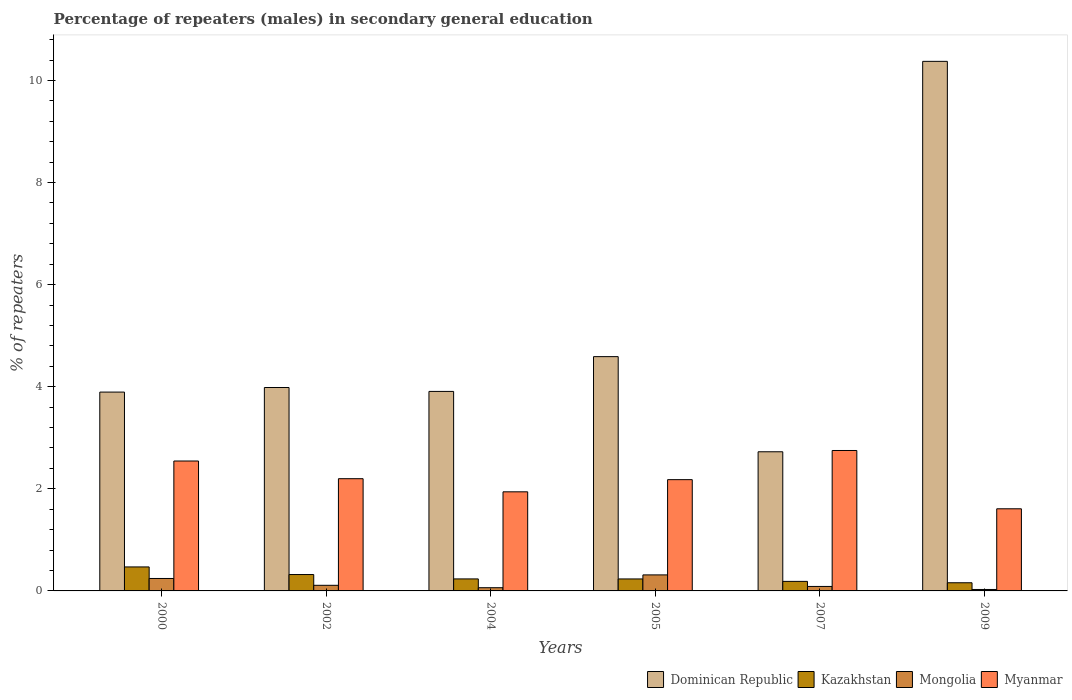How many different coloured bars are there?
Provide a succinct answer. 4. How many groups of bars are there?
Give a very brief answer. 6. Are the number of bars per tick equal to the number of legend labels?
Ensure brevity in your answer.  Yes. Are the number of bars on each tick of the X-axis equal?
Offer a very short reply. Yes. How many bars are there on the 4th tick from the left?
Provide a succinct answer. 4. How many bars are there on the 4th tick from the right?
Your answer should be very brief. 4. In how many cases, is the number of bars for a given year not equal to the number of legend labels?
Your response must be concise. 0. What is the percentage of male repeaters in Dominican Republic in 2009?
Make the answer very short. 10.37. Across all years, what is the maximum percentage of male repeaters in Dominican Republic?
Provide a succinct answer. 10.37. Across all years, what is the minimum percentage of male repeaters in Kazakhstan?
Your response must be concise. 0.16. What is the total percentage of male repeaters in Mongolia in the graph?
Your response must be concise. 0.85. What is the difference between the percentage of male repeaters in Kazakhstan in 2007 and that in 2009?
Ensure brevity in your answer.  0.03. What is the difference between the percentage of male repeaters in Mongolia in 2005 and the percentage of male repeaters in Myanmar in 2002?
Your answer should be very brief. -1.88. What is the average percentage of male repeaters in Dominican Republic per year?
Offer a terse response. 4.91. In the year 2004, what is the difference between the percentage of male repeaters in Kazakhstan and percentage of male repeaters in Myanmar?
Your answer should be compact. -1.71. In how many years, is the percentage of male repeaters in Mongolia greater than 4.8 %?
Offer a terse response. 0. What is the ratio of the percentage of male repeaters in Mongolia in 2002 to that in 2005?
Provide a succinct answer. 0.35. Is the percentage of male repeaters in Myanmar in 2004 less than that in 2005?
Your response must be concise. Yes. What is the difference between the highest and the second highest percentage of male repeaters in Dominican Republic?
Your answer should be very brief. 5.78. What is the difference between the highest and the lowest percentage of male repeaters in Myanmar?
Provide a short and direct response. 1.14. Is the sum of the percentage of male repeaters in Dominican Republic in 2002 and 2004 greater than the maximum percentage of male repeaters in Kazakhstan across all years?
Provide a short and direct response. Yes. Is it the case that in every year, the sum of the percentage of male repeaters in Myanmar and percentage of male repeaters in Dominican Republic is greater than the sum of percentage of male repeaters in Mongolia and percentage of male repeaters in Kazakhstan?
Make the answer very short. Yes. What does the 1st bar from the left in 2004 represents?
Keep it short and to the point. Dominican Republic. What does the 1st bar from the right in 2004 represents?
Make the answer very short. Myanmar. How many bars are there?
Your answer should be compact. 24. Are all the bars in the graph horizontal?
Offer a terse response. No. What is the difference between two consecutive major ticks on the Y-axis?
Your answer should be compact. 2. Does the graph contain grids?
Keep it short and to the point. No. How are the legend labels stacked?
Your answer should be compact. Horizontal. What is the title of the graph?
Provide a succinct answer. Percentage of repeaters (males) in secondary general education. What is the label or title of the Y-axis?
Your answer should be very brief. % of repeaters. What is the % of repeaters of Dominican Republic in 2000?
Provide a short and direct response. 3.9. What is the % of repeaters of Kazakhstan in 2000?
Keep it short and to the point. 0.47. What is the % of repeaters of Mongolia in 2000?
Provide a short and direct response. 0.24. What is the % of repeaters of Myanmar in 2000?
Make the answer very short. 2.55. What is the % of repeaters of Dominican Republic in 2002?
Give a very brief answer. 3.98. What is the % of repeaters of Kazakhstan in 2002?
Make the answer very short. 0.32. What is the % of repeaters of Mongolia in 2002?
Your answer should be very brief. 0.11. What is the % of repeaters in Myanmar in 2002?
Offer a terse response. 2.2. What is the % of repeaters of Dominican Republic in 2004?
Offer a terse response. 3.91. What is the % of repeaters of Kazakhstan in 2004?
Provide a short and direct response. 0.24. What is the % of repeaters of Mongolia in 2004?
Provide a short and direct response. 0.06. What is the % of repeaters of Myanmar in 2004?
Give a very brief answer. 1.94. What is the % of repeaters in Dominican Republic in 2005?
Provide a succinct answer. 4.59. What is the % of repeaters of Kazakhstan in 2005?
Offer a very short reply. 0.23. What is the % of repeaters of Mongolia in 2005?
Keep it short and to the point. 0.31. What is the % of repeaters in Myanmar in 2005?
Offer a terse response. 2.18. What is the % of repeaters in Dominican Republic in 2007?
Give a very brief answer. 2.73. What is the % of repeaters of Kazakhstan in 2007?
Offer a very short reply. 0.19. What is the % of repeaters of Mongolia in 2007?
Your answer should be very brief. 0.09. What is the % of repeaters of Myanmar in 2007?
Ensure brevity in your answer.  2.75. What is the % of repeaters in Dominican Republic in 2009?
Your answer should be compact. 10.37. What is the % of repeaters in Kazakhstan in 2009?
Ensure brevity in your answer.  0.16. What is the % of repeaters of Mongolia in 2009?
Ensure brevity in your answer.  0.03. What is the % of repeaters in Myanmar in 2009?
Keep it short and to the point. 1.61. Across all years, what is the maximum % of repeaters of Dominican Republic?
Keep it short and to the point. 10.37. Across all years, what is the maximum % of repeaters of Kazakhstan?
Offer a very short reply. 0.47. Across all years, what is the maximum % of repeaters of Mongolia?
Offer a very short reply. 0.31. Across all years, what is the maximum % of repeaters in Myanmar?
Make the answer very short. 2.75. Across all years, what is the minimum % of repeaters in Dominican Republic?
Your response must be concise. 2.73. Across all years, what is the minimum % of repeaters in Kazakhstan?
Offer a terse response. 0.16. Across all years, what is the minimum % of repeaters in Mongolia?
Make the answer very short. 0.03. Across all years, what is the minimum % of repeaters of Myanmar?
Make the answer very short. 1.61. What is the total % of repeaters of Dominican Republic in the graph?
Ensure brevity in your answer.  29.48. What is the total % of repeaters of Kazakhstan in the graph?
Offer a very short reply. 1.61. What is the total % of repeaters in Mongolia in the graph?
Ensure brevity in your answer.  0.85. What is the total % of repeaters in Myanmar in the graph?
Your answer should be compact. 13.22. What is the difference between the % of repeaters in Dominican Republic in 2000 and that in 2002?
Give a very brief answer. -0.09. What is the difference between the % of repeaters in Kazakhstan in 2000 and that in 2002?
Ensure brevity in your answer.  0.15. What is the difference between the % of repeaters of Mongolia in 2000 and that in 2002?
Ensure brevity in your answer.  0.13. What is the difference between the % of repeaters in Myanmar in 2000 and that in 2002?
Ensure brevity in your answer.  0.35. What is the difference between the % of repeaters in Dominican Republic in 2000 and that in 2004?
Keep it short and to the point. -0.01. What is the difference between the % of repeaters of Kazakhstan in 2000 and that in 2004?
Offer a very short reply. 0.23. What is the difference between the % of repeaters in Mongolia in 2000 and that in 2004?
Your response must be concise. 0.18. What is the difference between the % of repeaters in Myanmar in 2000 and that in 2004?
Offer a very short reply. 0.6. What is the difference between the % of repeaters of Dominican Republic in 2000 and that in 2005?
Keep it short and to the point. -0.69. What is the difference between the % of repeaters in Kazakhstan in 2000 and that in 2005?
Keep it short and to the point. 0.24. What is the difference between the % of repeaters in Mongolia in 2000 and that in 2005?
Your answer should be compact. -0.07. What is the difference between the % of repeaters of Myanmar in 2000 and that in 2005?
Your response must be concise. 0.37. What is the difference between the % of repeaters of Dominican Republic in 2000 and that in 2007?
Provide a succinct answer. 1.17. What is the difference between the % of repeaters in Kazakhstan in 2000 and that in 2007?
Your answer should be compact. 0.28. What is the difference between the % of repeaters in Mongolia in 2000 and that in 2007?
Provide a short and direct response. 0.16. What is the difference between the % of repeaters in Myanmar in 2000 and that in 2007?
Offer a terse response. -0.21. What is the difference between the % of repeaters of Dominican Republic in 2000 and that in 2009?
Keep it short and to the point. -6.48. What is the difference between the % of repeaters of Kazakhstan in 2000 and that in 2009?
Keep it short and to the point. 0.31. What is the difference between the % of repeaters of Mongolia in 2000 and that in 2009?
Offer a very short reply. 0.22. What is the difference between the % of repeaters of Myanmar in 2000 and that in 2009?
Make the answer very short. 0.94. What is the difference between the % of repeaters of Dominican Republic in 2002 and that in 2004?
Make the answer very short. 0.08. What is the difference between the % of repeaters of Kazakhstan in 2002 and that in 2004?
Provide a succinct answer. 0.09. What is the difference between the % of repeaters of Mongolia in 2002 and that in 2004?
Make the answer very short. 0.05. What is the difference between the % of repeaters of Myanmar in 2002 and that in 2004?
Make the answer very short. 0.26. What is the difference between the % of repeaters of Dominican Republic in 2002 and that in 2005?
Ensure brevity in your answer.  -0.6. What is the difference between the % of repeaters of Kazakhstan in 2002 and that in 2005?
Give a very brief answer. 0.09. What is the difference between the % of repeaters of Mongolia in 2002 and that in 2005?
Provide a short and direct response. -0.2. What is the difference between the % of repeaters of Myanmar in 2002 and that in 2005?
Your answer should be very brief. 0.02. What is the difference between the % of repeaters of Dominican Republic in 2002 and that in 2007?
Your response must be concise. 1.26. What is the difference between the % of repeaters in Kazakhstan in 2002 and that in 2007?
Keep it short and to the point. 0.13. What is the difference between the % of repeaters of Mongolia in 2002 and that in 2007?
Provide a succinct answer. 0.02. What is the difference between the % of repeaters in Myanmar in 2002 and that in 2007?
Offer a terse response. -0.55. What is the difference between the % of repeaters of Dominican Republic in 2002 and that in 2009?
Keep it short and to the point. -6.39. What is the difference between the % of repeaters of Kazakhstan in 2002 and that in 2009?
Your answer should be compact. 0.16. What is the difference between the % of repeaters of Mongolia in 2002 and that in 2009?
Give a very brief answer. 0.08. What is the difference between the % of repeaters of Myanmar in 2002 and that in 2009?
Ensure brevity in your answer.  0.59. What is the difference between the % of repeaters in Dominican Republic in 2004 and that in 2005?
Give a very brief answer. -0.68. What is the difference between the % of repeaters of Kazakhstan in 2004 and that in 2005?
Keep it short and to the point. 0. What is the difference between the % of repeaters of Mongolia in 2004 and that in 2005?
Your answer should be very brief. -0.25. What is the difference between the % of repeaters of Myanmar in 2004 and that in 2005?
Provide a succinct answer. -0.24. What is the difference between the % of repeaters in Dominican Republic in 2004 and that in 2007?
Provide a short and direct response. 1.18. What is the difference between the % of repeaters in Kazakhstan in 2004 and that in 2007?
Provide a succinct answer. 0.05. What is the difference between the % of repeaters of Mongolia in 2004 and that in 2007?
Make the answer very short. -0.02. What is the difference between the % of repeaters in Myanmar in 2004 and that in 2007?
Offer a very short reply. -0.81. What is the difference between the % of repeaters in Dominican Republic in 2004 and that in 2009?
Make the answer very short. -6.47. What is the difference between the % of repeaters of Kazakhstan in 2004 and that in 2009?
Your response must be concise. 0.08. What is the difference between the % of repeaters in Mongolia in 2004 and that in 2009?
Keep it short and to the point. 0.03. What is the difference between the % of repeaters of Myanmar in 2004 and that in 2009?
Your answer should be very brief. 0.33. What is the difference between the % of repeaters of Dominican Republic in 2005 and that in 2007?
Offer a terse response. 1.86. What is the difference between the % of repeaters of Kazakhstan in 2005 and that in 2007?
Keep it short and to the point. 0.05. What is the difference between the % of repeaters in Mongolia in 2005 and that in 2007?
Your answer should be very brief. 0.23. What is the difference between the % of repeaters of Myanmar in 2005 and that in 2007?
Offer a terse response. -0.57. What is the difference between the % of repeaters of Dominican Republic in 2005 and that in 2009?
Make the answer very short. -5.78. What is the difference between the % of repeaters in Kazakhstan in 2005 and that in 2009?
Your answer should be compact. 0.07. What is the difference between the % of repeaters in Mongolia in 2005 and that in 2009?
Your answer should be compact. 0.29. What is the difference between the % of repeaters in Myanmar in 2005 and that in 2009?
Keep it short and to the point. 0.57. What is the difference between the % of repeaters in Dominican Republic in 2007 and that in 2009?
Offer a terse response. -7.65. What is the difference between the % of repeaters in Kazakhstan in 2007 and that in 2009?
Keep it short and to the point. 0.03. What is the difference between the % of repeaters in Mongolia in 2007 and that in 2009?
Offer a terse response. 0.06. What is the difference between the % of repeaters of Myanmar in 2007 and that in 2009?
Provide a short and direct response. 1.14. What is the difference between the % of repeaters of Dominican Republic in 2000 and the % of repeaters of Kazakhstan in 2002?
Ensure brevity in your answer.  3.57. What is the difference between the % of repeaters of Dominican Republic in 2000 and the % of repeaters of Mongolia in 2002?
Provide a short and direct response. 3.79. What is the difference between the % of repeaters in Dominican Republic in 2000 and the % of repeaters in Myanmar in 2002?
Offer a terse response. 1.7. What is the difference between the % of repeaters in Kazakhstan in 2000 and the % of repeaters in Mongolia in 2002?
Offer a very short reply. 0.36. What is the difference between the % of repeaters of Kazakhstan in 2000 and the % of repeaters of Myanmar in 2002?
Provide a succinct answer. -1.73. What is the difference between the % of repeaters in Mongolia in 2000 and the % of repeaters in Myanmar in 2002?
Offer a terse response. -1.95. What is the difference between the % of repeaters of Dominican Republic in 2000 and the % of repeaters of Kazakhstan in 2004?
Provide a short and direct response. 3.66. What is the difference between the % of repeaters in Dominican Republic in 2000 and the % of repeaters in Mongolia in 2004?
Your response must be concise. 3.83. What is the difference between the % of repeaters in Dominican Republic in 2000 and the % of repeaters in Myanmar in 2004?
Give a very brief answer. 1.95. What is the difference between the % of repeaters of Kazakhstan in 2000 and the % of repeaters of Mongolia in 2004?
Give a very brief answer. 0.41. What is the difference between the % of repeaters of Kazakhstan in 2000 and the % of repeaters of Myanmar in 2004?
Ensure brevity in your answer.  -1.47. What is the difference between the % of repeaters of Mongolia in 2000 and the % of repeaters of Myanmar in 2004?
Ensure brevity in your answer.  -1.7. What is the difference between the % of repeaters of Dominican Republic in 2000 and the % of repeaters of Kazakhstan in 2005?
Your response must be concise. 3.66. What is the difference between the % of repeaters of Dominican Republic in 2000 and the % of repeaters of Mongolia in 2005?
Provide a succinct answer. 3.58. What is the difference between the % of repeaters in Dominican Republic in 2000 and the % of repeaters in Myanmar in 2005?
Your answer should be very brief. 1.72. What is the difference between the % of repeaters in Kazakhstan in 2000 and the % of repeaters in Mongolia in 2005?
Give a very brief answer. 0.16. What is the difference between the % of repeaters in Kazakhstan in 2000 and the % of repeaters in Myanmar in 2005?
Your response must be concise. -1.71. What is the difference between the % of repeaters in Mongolia in 2000 and the % of repeaters in Myanmar in 2005?
Ensure brevity in your answer.  -1.94. What is the difference between the % of repeaters in Dominican Republic in 2000 and the % of repeaters in Kazakhstan in 2007?
Keep it short and to the point. 3.71. What is the difference between the % of repeaters in Dominican Republic in 2000 and the % of repeaters in Mongolia in 2007?
Offer a very short reply. 3.81. What is the difference between the % of repeaters in Dominican Republic in 2000 and the % of repeaters in Myanmar in 2007?
Make the answer very short. 1.14. What is the difference between the % of repeaters of Kazakhstan in 2000 and the % of repeaters of Mongolia in 2007?
Make the answer very short. 0.38. What is the difference between the % of repeaters in Kazakhstan in 2000 and the % of repeaters in Myanmar in 2007?
Keep it short and to the point. -2.28. What is the difference between the % of repeaters of Mongolia in 2000 and the % of repeaters of Myanmar in 2007?
Provide a short and direct response. -2.51. What is the difference between the % of repeaters in Dominican Republic in 2000 and the % of repeaters in Kazakhstan in 2009?
Ensure brevity in your answer.  3.74. What is the difference between the % of repeaters in Dominican Republic in 2000 and the % of repeaters in Mongolia in 2009?
Offer a terse response. 3.87. What is the difference between the % of repeaters of Dominican Republic in 2000 and the % of repeaters of Myanmar in 2009?
Offer a terse response. 2.29. What is the difference between the % of repeaters of Kazakhstan in 2000 and the % of repeaters of Mongolia in 2009?
Offer a terse response. 0.44. What is the difference between the % of repeaters of Kazakhstan in 2000 and the % of repeaters of Myanmar in 2009?
Your answer should be very brief. -1.14. What is the difference between the % of repeaters of Mongolia in 2000 and the % of repeaters of Myanmar in 2009?
Offer a terse response. -1.37. What is the difference between the % of repeaters of Dominican Republic in 2002 and the % of repeaters of Kazakhstan in 2004?
Keep it short and to the point. 3.75. What is the difference between the % of repeaters of Dominican Republic in 2002 and the % of repeaters of Mongolia in 2004?
Your response must be concise. 3.92. What is the difference between the % of repeaters of Dominican Republic in 2002 and the % of repeaters of Myanmar in 2004?
Offer a very short reply. 2.04. What is the difference between the % of repeaters of Kazakhstan in 2002 and the % of repeaters of Mongolia in 2004?
Ensure brevity in your answer.  0.26. What is the difference between the % of repeaters in Kazakhstan in 2002 and the % of repeaters in Myanmar in 2004?
Offer a terse response. -1.62. What is the difference between the % of repeaters of Mongolia in 2002 and the % of repeaters of Myanmar in 2004?
Offer a terse response. -1.83. What is the difference between the % of repeaters in Dominican Republic in 2002 and the % of repeaters in Kazakhstan in 2005?
Keep it short and to the point. 3.75. What is the difference between the % of repeaters in Dominican Republic in 2002 and the % of repeaters in Mongolia in 2005?
Provide a succinct answer. 3.67. What is the difference between the % of repeaters in Dominican Republic in 2002 and the % of repeaters in Myanmar in 2005?
Provide a succinct answer. 1.8. What is the difference between the % of repeaters in Kazakhstan in 2002 and the % of repeaters in Mongolia in 2005?
Offer a terse response. 0.01. What is the difference between the % of repeaters in Kazakhstan in 2002 and the % of repeaters in Myanmar in 2005?
Provide a short and direct response. -1.86. What is the difference between the % of repeaters of Mongolia in 2002 and the % of repeaters of Myanmar in 2005?
Provide a succinct answer. -2.07. What is the difference between the % of repeaters of Dominican Republic in 2002 and the % of repeaters of Kazakhstan in 2007?
Ensure brevity in your answer.  3.8. What is the difference between the % of repeaters of Dominican Republic in 2002 and the % of repeaters of Mongolia in 2007?
Give a very brief answer. 3.9. What is the difference between the % of repeaters in Dominican Republic in 2002 and the % of repeaters in Myanmar in 2007?
Give a very brief answer. 1.23. What is the difference between the % of repeaters in Kazakhstan in 2002 and the % of repeaters in Mongolia in 2007?
Give a very brief answer. 0.23. What is the difference between the % of repeaters in Kazakhstan in 2002 and the % of repeaters in Myanmar in 2007?
Ensure brevity in your answer.  -2.43. What is the difference between the % of repeaters of Mongolia in 2002 and the % of repeaters of Myanmar in 2007?
Offer a very short reply. -2.64. What is the difference between the % of repeaters of Dominican Republic in 2002 and the % of repeaters of Kazakhstan in 2009?
Offer a very short reply. 3.82. What is the difference between the % of repeaters in Dominican Republic in 2002 and the % of repeaters in Mongolia in 2009?
Provide a succinct answer. 3.96. What is the difference between the % of repeaters of Dominican Republic in 2002 and the % of repeaters of Myanmar in 2009?
Give a very brief answer. 2.38. What is the difference between the % of repeaters of Kazakhstan in 2002 and the % of repeaters of Mongolia in 2009?
Provide a succinct answer. 0.29. What is the difference between the % of repeaters in Kazakhstan in 2002 and the % of repeaters in Myanmar in 2009?
Your answer should be very brief. -1.29. What is the difference between the % of repeaters in Mongolia in 2002 and the % of repeaters in Myanmar in 2009?
Your answer should be compact. -1.5. What is the difference between the % of repeaters of Dominican Republic in 2004 and the % of repeaters of Kazakhstan in 2005?
Offer a very short reply. 3.67. What is the difference between the % of repeaters of Dominican Republic in 2004 and the % of repeaters of Mongolia in 2005?
Offer a very short reply. 3.59. What is the difference between the % of repeaters of Dominican Republic in 2004 and the % of repeaters of Myanmar in 2005?
Make the answer very short. 1.73. What is the difference between the % of repeaters in Kazakhstan in 2004 and the % of repeaters in Mongolia in 2005?
Give a very brief answer. -0.08. What is the difference between the % of repeaters of Kazakhstan in 2004 and the % of repeaters of Myanmar in 2005?
Provide a short and direct response. -1.94. What is the difference between the % of repeaters of Mongolia in 2004 and the % of repeaters of Myanmar in 2005?
Ensure brevity in your answer.  -2.12. What is the difference between the % of repeaters in Dominican Republic in 2004 and the % of repeaters in Kazakhstan in 2007?
Offer a very short reply. 3.72. What is the difference between the % of repeaters of Dominican Republic in 2004 and the % of repeaters of Mongolia in 2007?
Ensure brevity in your answer.  3.82. What is the difference between the % of repeaters of Dominican Republic in 2004 and the % of repeaters of Myanmar in 2007?
Give a very brief answer. 1.16. What is the difference between the % of repeaters in Kazakhstan in 2004 and the % of repeaters in Mongolia in 2007?
Ensure brevity in your answer.  0.15. What is the difference between the % of repeaters in Kazakhstan in 2004 and the % of repeaters in Myanmar in 2007?
Provide a short and direct response. -2.52. What is the difference between the % of repeaters in Mongolia in 2004 and the % of repeaters in Myanmar in 2007?
Offer a terse response. -2.69. What is the difference between the % of repeaters in Dominican Republic in 2004 and the % of repeaters in Kazakhstan in 2009?
Offer a terse response. 3.75. What is the difference between the % of repeaters in Dominican Republic in 2004 and the % of repeaters in Mongolia in 2009?
Your answer should be compact. 3.88. What is the difference between the % of repeaters in Dominican Republic in 2004 and the % of repeaters in Myanmar in 2009?
Ensure brevity in your answer.  2.3. What is the difference between the % of repeaters of Kazakhstan in 2004 and the % of repeaters of Mongolia in 2009?
Give a very brief answer. 0.21. What is the difference between the % of repeaters in Kazakhstan in 2004 and the % of repeaters in Myanmar in 2009?
Ensure brevity in your answer.  -1.37. What is the difference between the % of repeaters in Mongolia in 2004 and the % of repeaters in Myanmar in 2009?
Offer a very short reply. -1.55. What is the difference between the % of repeaters of Dominican Republic in 2005 and the % of repeaters of Kazakhstan in 2007?
Provide a short and direct response. 4.4. What is the difference between the % of repeaters of Dominican Republic in 2005 and the % of repeaters of Mongolia in 2007?
Ensure brevity in your answer.  4.5. What is the difference between the % of repeaters in Dominican Republic in 2005 and the % of repeaters in Myanmar in 2007?
Offer a terse response. 1.84. What is the difference between the % of repeaters of Kazakhstan in 2005 and the % of repeaters of Mongolia in 2007?
Give a very brief answer. 0.15. What is the difference between the % of repeaters in Kazakhstan in 2005 and the % of repeaters in Myanmar in 2007?
Offer a very short reply. -2.52. What is the difference between the % of repeaters in Mongolia in 2005 and the % of repeaters in Myanmar in 2007?
Your answer should be compact. -2.44. What is the difference between the % of repeaters in Dominican Republic in 2005 and the % of repeaters in Kazakhstan in 2009?
Ensure brevity in your answer.  4.43. What is the difference between the % of repeaters of Dominican Republic in 2005 and the % of repeaters of Mongolia in 2009?
Provide a short and direct response. 4.56. What is the difference between the % of repeaters of Dominican Republic in 2005 and the % of repeaters of Myanmar in 2009?
Keep it short and to the point. 2.98. What is the difference between the % of repeaters in Kazakhstan in 2005 and the % of repeaters in Mongolia in 2009?
Your answer should be compact. 0.21. What is the difference between the % of repeaters of Kazakhstan in 2005 and the % of repeaters of Myanmar in 2009?
Offer a very short reply. -1.37. What is the difference between the % of repeaters in Mongolia in 2005 and the % of repeaters in Myanmar in 2009?
Provide a succinct answer. -1.3. What is the difference between the % of repeaters in Dominican Republic in 2007 and the % of repeaters in Kazakhstan in 2009?
Your response must be concise. 2.57. What is the difference between the % of repeaters of Dominican Republic in 2007 and the % of repeaters of Mongolia in 2009?
Offer a very short reply. 2.7. What is the difference between the % of repeaters of Dominican Republic in 2007 and the % of repeaters of Myanmar in 2009?
Provide a succinct answer. 1.12. What is the difference between the % of repeaters of Kazakhstan in 2007 and the % of repeaters of Mongolia in 2009?
Offer a terse response. 0.16. What is the difference between the % of repeaters of Kazakhstan in 2007 and the % of repeaters of Myanmar in 2009?
Make the answer very short. -1.42. What is the difference between the % of repeaters in Mongolia in 2007 and the % of repeaters in Myanmar in 2009?
Provide a short and direct response. -1.52. What is the average % of repeaters in Dominican Republic per year?
Your answer should be compact. 4.91. What is the average % of repeaters in Kazakhstan per year?
Offer a terse response. 0.27. What is the average % of repeaters of Mongolia per year?
Keep it short and to the point. 0.14. What is the average % of repeaters of Myanmar per year?
Keep it short and to the point. 2.2. In the year 2000, what is the difference between the % of repeaters of Dominican Republic and % of repeaters of Kazakhstan?
Your answer should be compact. 3.43. In the year 2000, what is the difference between the % of repeaters in Dominican Republic and % of repeaters in Mongolia?
Keep it short and to the point. 3.65. In the year 2000, what is the difference between the % of repeaters of Dominican Republic and % of repeaters of Myanmar?
Give a very brief answer. 1.35. In the year 2000, what is the difference between the % of repeaters in Kazakhstan and % of repeaters in Mongolia?
Give a very brief answer. 0.23. In the year 2000, what is the difference between the % of repeaters in Kazakhstan and % of repeaters in Myanmar?
Ensure brevity in your answer.  -2.08. In the year 2000, what is the difference between the % of repeaters in Mongolia and % of repeaters in Myanmar?
Keep it short and to the point. -2.3. In the year 2002, what is the difference between the % of repeaters of Dominican Republic and % of repeaters of Kazakhstan?
Offer a very short reply. 3.66. In the year 2002, what is the difference between the % of repeaters in Dominican Republic and % of repeaters in Mongolia?
Your answer should be very brief. 3.87. In the year 2002, what is the difference between the % of repeaters in Dominican Republic and % of repeaters in Myanmar?
Offer a very short reply. 1.79. In the year 2002, what is the difference between the % of repeaters in Kazakhstan and % of repeaters in Mongolia?
Offer a terse response. 0.21. In the year 2002, what is the difference between the % of repeaters in Kazakhstan and % of repeaters in Myanmar?
Provide a succinct answer. -1.88. In the year 2002, what is the difference between the % of repeaters in Mongolia and % of repeaters in Myanmar?
Provide a succinct answer. -2.09. In the year 2004, what is the difference between the % of repeaters in Dominican Republic and % of repeaters in Kazakhstan?
Provide a succinct answer. 3.67. In the year 2004, what is the difference between the % of repeaters in Dominican Republic and % of repeaters in Mongolia?
Keep it short and to the point. 3.85. In the year 2004, what is the difference between the % of repeaters in Dominican Republic and % of repeaters in Myanmar?
Ensure brevity in your answer.  1.97. In the year 2004, what is the difference between the % of repeaters in Kazakhstan and % of repeaters in Mongolia?
Provide a short and direct response. 0.17. In the year 2004, what is the difference between the % of repeaters of Kazakhstan and % of repeaters of Myanmar?
Make the answer very short. -1.71. In the year 2004, what is the difference between the % of repeaters in Mongolia and % of repeaters in Myanmar?
Your answer should be very brief. -1.88. In the year 2005, what is the difference between the % of repeaters of Dominican Republic and % of repeaters of Kazakhstan?
Offer a terse response. 4.36. In the year 2005, what is the difference between the % of repeaters in Dominican Republic and % of repeaters in Mongolia?
Keep it short and to the point. 4.28. In the year 2005, what is the difference between the % of repeaters in Dominican Republic and % of repeaters in Myanmar?
Keep it short and to the point. 2.41. In the year 2005, what is the difference between the % of repeaters of Kazakhstan and % of repeaters of Mongolia?
Your response must be concise. -0.08. In the year 2005, what is the difference between the % of repeaters of Kazakhstan and % of repeaters of Myanmar?
Provide a succinct answer. -1.95. In the year 2005, what is the difference between the % of repeaters in Mongolia and % of repeaters in Myanmar?
Make the answer very short. -1.87. In the year 2007, what is the difference between the % of repeaters of Dominican Republic and % of repeaters of Kazakhstan?
Your answer should be very brief. 2.54. In the year 2007, what is the difference between the % of repeaters in Dominican Republic and % of repeaters in Mongolia?
Your answer should be very brief. 2.64. In the year 2007, what is the difference between the % of repeaters in Dominican Republic and % of repeaters in Myanmar?
Provide a short and direct response. -0.03. In the year 2007, what is the difference between the % of repeaters in Kazakhstan and % of repeaters in Mongolia?
Ensure brevity in your answer.  0.1. In the year 2007, what is the difference between the % of repeaters of Kazakhstan and % of repeaters of Myanmar?
Keep it short and to the point. -2.56. In the year 2007, what is the difference between the % of repeaters of Mongolia and % of repeaters of Myanmar?
Keep it short and to the point. -2.66. In the year 2009, what is the difference between the % of repeaters in Dominican Republic and % of repeaters in Kazakhstan?
Ensure brevity in your answer.  10.21. In the year 2009, what is the difference between the % of repeaters in Dominican Republic and % of repeaters in Mongolia?
Your answer should be very brief. 10.35. In the year 2009, what is the difference between the % of repeaters in Dominican Republic and % of repeaters in Myanmar?
Your answer should be very brief. 8.77. In the year 2009, what is the difference between the % of repeaters in Kazakhstan and % of repeaters in Mongolia?
Give a very brief answer. 0.13. In the year 2009, what is the difference between the % of repeaters in Kazakhstan and % of repeaters in Myanmar?
Offer a terse response. -1.45. In the year 2009, what is the difference between the % of repeaters of Mongolia and % of repeaters of Myanmar?
Offer a terse response. -1.58. What is the ratio of the % of repeaters in Dominican Republic in 2000 to that in 2002?
Make the answer very short. 0.98. What is the ratio of the % of repeaters in Kazakhstan in 2000 to that in 2002?
Offer a very short reply. 1.46. What is the ratio of the % of repeaters in Mongolia in 2000 to that in 2002?
Offer a very short reply. 2.21. What is the ratio of the % of repeaters of Myanmar in 2000 to that in 2002?
Provide a short and direct response. 1.16. What is the ratio of the % of repeaters of Kazakhstan in 2000 to that in 2004?
Make the answer very short. 2. What is the ratio of the % of repeaters in Mongolia in 2000 to that in 2004?
Offer a terse response. 3.87. What is the ratio of the % of repeaters of Myanmar in 2000 to that in 2004?
Offer a terse response. 1.31. What is the ratio of the % of repeaters in Dominican Republic in 2000 to that in 2005?
Offer a very short reply. 0.85. What is the ratio of the % of repeaters in Kazakhstan in 2000 to that in 2005?
Give a very brief answer. 2. What is the ratio of the % of repeaters of Mongolia in 2000 to that in 2005?
Ensure brevity in your answer.  0.78. What is the ratio of the % of repeaters in Myanmar in 2000 to that in 2005?
Make the answer very short. 1.17. What is the ratio of the % of repeaters in Dominican Republic in 2000 to that in 2007?
Your answer should be compact. 1.43. What is the ratio of the % of repeaters of Kazakhstan in 2000 to that in 2007?
Provide a short and direct response. 2.51. What is the ratio of the % of repeaters of Mongolia in 2000 to that in 2007?
Provide a succinct answer. 2.78. What is the ratio of the % of repeaters of Myanmar in 2000 to that in 2007?
Offer a terse response. 0.93. What is the ratio of the % of repeaters of Dominican Republic in 2000 to that in 2009?
Your answer should be compact. 0.38. What is the ratio of the % of repeaters of Kazakhstan in 2000 to that in 2009?
Provide a succinct answer. 2.94. What is the ratio of the % of repeaters in Mongolia in 2000 to that in 2009?
Your response must be concise. 8.62. What is the ratio of the % of repeaters of Myanmar in 2000 to that in 2009?
Keep it short and to the point. 1.58. What is the ratio of the % of repeaters in Dominican Republic in 2002 to that in 2004?
Make the answer very short. 1.02. What is the ratio of the % of repeaters of Kazakhstan in 2002 to that in 2004?
Offer a terse response. 1.36. What is the ratio of the % of repeaters in Mongolia in 2002 to that in 2004?
Keep it short and to the point. 1.75. What is the ratio of the % of repeaters in Myanmar in 2002 to that in 2004?
Make the answer very short. 1.13. What is the ratio of the % of repeaters in Dominican Republic in 2002 to that in 2005?
Provide a succinct answer. 0.87. What is the ratio of the % of repeaters in Kazakhstan in 2002 to that in 2005?
Give a very brief answer. 1.37. What is the ratio of the % of repeaters of Mongolia in 2002 to that in 2005?
Your answer should be compact. 0.35. What is the ratio of the % of repeaters of Myanmar in 2002 to that in 2005?
Provide a short and direct response. 1.01. What is the ratio of the % of repeaters in Dominican Republic in 2002 to that in 2007?
Offer a very short reply. 1.46. What is the ratio of the % of repeaters in Kazakhstan in 2002 to that in 2007?
Offer a terse response. 1.72. What is the ratio of the % of repeaters in Mongolia in 2002 to that in 2007?
Provide a succinct answer. 1.25. What is the ratio of the % of repeaters of Myanmar in 2002 to that in 2007?
Keep it short and to the point. 0.8. What is the ratio of the % of repeaters in Dominican Republic in 2002 to that in 2009?
Offer a terse response. 0.38. What is the ratio of the % of repeaters in Kazakhstan in 2002 to that in 2009?
Give a very brief answer. 2.01. What is the ratio of the % of repeaters in Mongolia in 2002 to that in 2009?
Provide a succinct answer. 3.89. What is the ratio of the % of repeaters in Myanmar in 2002 to that in 2009?
Offer a terse response. 1.37. What is the ratio of the % of repeaters in Dominican Republic in 2004 to that in 2005?
Your answer should be compact. 0.85. What is the ratio of the % of repeaters in Kazakhstan in 2004 to that in 2005?
Offer a very short reply. 1. What is the ratio of the % of repeaters in Mongolia in 2004 to that in 2005?
Give a very brief answer. 0.2. What is the ratio of the % of repeaters in Myanmar in 2004 to that in 2005?
Offer a terse response. 0.89. What is the ratio of the % of repeaters of Dominican Republic in 2004 to that in 2007?
Offer a terse response. 1.43. What is the ratio of the % of repeaters in Kazakhstan in 2004 to that in 2007?
Give a very brief answer. 1.26. What is the ratio of the % of repeaters of Mongolia in 2004 to that in 2007?
Ensure brevity in your answer.  0.72. What is the ratio of the % of repeaters of Myanmar in 2004 to that in 2007?
Offer a terse response. 0.71. What is the ratio of the % of repeaters of Dominican Republic in 2004 to that in 2009?
Your answer should be compact. 0.38. What is the ratio of the % of repeaters in Kazakhstan in 2004 to that in 2009?
Offer a very short reply. 1.47. What is the ratio of the % of repeaters in Mongolia in 2004 to that in 2009?
Offer a very short reply. 2.23. What is the ratio of the % of repeaters of Myanmar in 2004 to that in 2009?
Ensure brevity in your answer.  1.21. What is the ratio of the % of repeaters in Dominican Republic in 2005 to that in 2007?
Provide a succinct answer. 1.68. What is the ratio of the % of repeaters in Kazakhstan in 2005 to that in 2007?
Offer a very short reply. 1.26. What is the ratio of the % of repeaters in Mongolia in 2005 to that in 2007?
Offer a terse response. 3.58. What is the ratio of the % of repeaters of Myanmar in 2005 to that in 2007?
Keep it short and to the point. 0.79. What is the ratio of the % of repeaters of Dominican Republic in 2005 to that in 2009?
Offer a terse response. 0.44. What is the ratio of the % of repeaters in Kazakhstan in 2005 to that in 2009?
Your response must be concise. 1.47. What is the ratio of the % of repeaters in Mongolia in 2005 to that in 2009?
Your answer should be compact. 11.11. What is the ratio of the % of repeaters of Myanmar in 2005 to that in 2009?
Give a very brief answer. 1.35. What is the ratio of the % of repeaters in Dominican Republic in 2007 to that in 2009?
Ensure brevity in your answer.  0.26. What is the ratio of the % of repeaters in Kazakhstan in 2007 to that in 2009?
Ensure brevity in your answer.  1.17. What is the ratio of the % of repeaters of Mongolia in 2007 to that in 2009?
Provide a succinct answer. 3.1. What is the ratio of the % of repeaters in Myanmar in 2007 to that in 2009?
Give a very brief answer. 1.71. What is the difference between the highest and the second highest % of repeaters in Dominican Republic?
Give a very brief answer. 5.78. What is the difference between the highest and the second highest % of repeaters of Kazakhstan?
Provide a succinct answer. 0.15. What is the difference between the highest and the second highest % of repeaters of Mongolia?
Offer a very short reply. 0.07. What is the difference between the highest and the second highest % of repeaters in Myanmar?
Your answer should be compact. 0.21. What is the difference between the highest and the lowest % of repeaters of Dominican Republic?
Offer a very short reply. 7.65. What is the difference between the highest and the lowest % of repeaters of Kazakhstan?
Your answer should be compact. 0.31. What is the difference between the highest and the lowest % of repeaters of Mongolia?
Make the answer very short. 0.29. What is the difference between the highest and the lowest % of repeaters of Myanmar?
Make the answer very short. 1.14. 